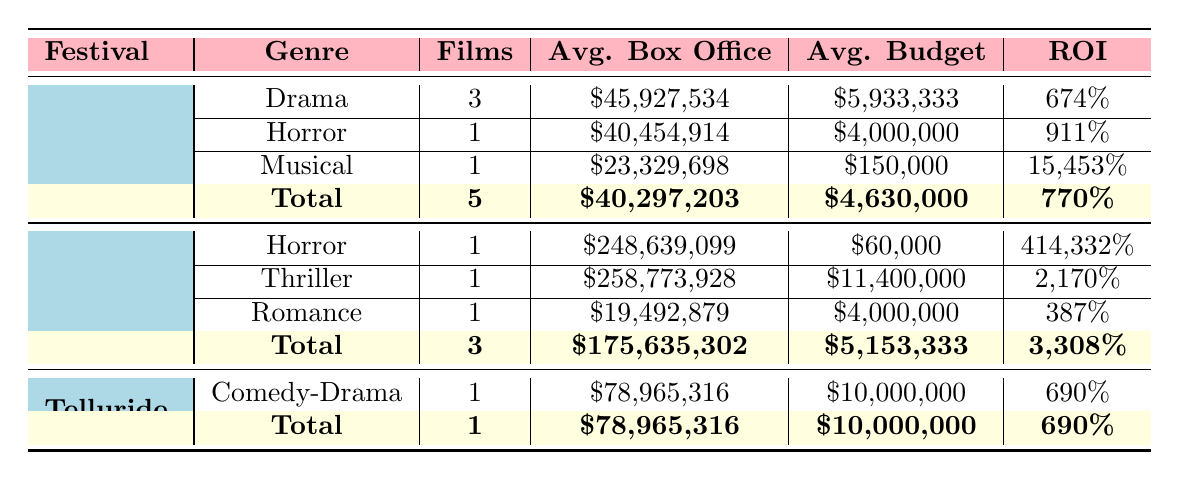What is the average box office for films at Sundance? In the Sundance festival row, the average box office for the three drama films is 45,927,534, for the horror film is 40,454,914, and for the musical is 23,329,698. The overall average box office can be calculated from the total of five films, which is (45,927,534 + 40,454,914 + 23,329,698) / 5 = 40,297,203.
Answer: 40,297,203 How many films are listed under the Cannes festival? The Cannes festival row has three genres along with a total section at the bottom. The individual genres include horror, thriller, and romance, each counting for one film, leading to a total of three films.
Answer: 3 What is the box office performance of the film with the highest ROI? The table indicates that the horror film at Cannes has an ROI of 414,332%, while the musical at Sundance has an exceptional ROI of 15,453%. Therefore, the musical has the highest ROI. The box office performance, or earnings of the film, can be found in the Sundance section indicating the earnings to be 23,329,698.
Answer: 23,329,698 Is the average budget for films at Cannes higher or lower than for films at Sundance? First, we examine the average budget for Sundance, which is \$4,630,000, and the average budget for Cannes, which is \$5,153,333. By comparing both values, \$5,153,333 is higher than \$4,630,000.
Answer: Higher What is the total average box office across all festivals? To find the total average box office, sum the average box office for Sundance (40,297,203), Cannes (175,635,302), and Telluride (78,965,316). The total average can then be calculated as follows: (40,297,203 + 175,635,302 + 78,965,316) / 3 = 98,965,274.
Answer: 98,965,274 How many horror films were showcased at major festivals, and what was their average box office? The Sundance festival has one horror film with box office earnings of 40,454,914, and the Cannes festival has a horror film with box office earnings of 248,639,099. Adding these gives a total of two horror films with box office earnings of 289,094,013. Therefore, the average box office can be calculated as 289,094,013 / 2 = 144,547,006.5.
Answer: 144,547,006.5 Did any film at the Sundance festival win more than two awards? Upon inspecting the Sundance section, we find that "Moonlight" and "Whiplash" each won three awards, which is more than two. Therefore, the answer is yes.
Answer: Yes What genre had the highest average box office in the Sundance festival? The box office for each film genre under Sundance includes: Drama (3 films) had an average of 45,927,534, Horror (1 film) had an average of 40,454,914, and Musical (1 film) had 23,329,698. By comparing these averages, Drama has the highest average box office.
Answer: Drama 